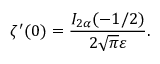Convert formula to latex. <formula><loc_0><loc_0><loc_500><loc_500>\zeta ^ { \prime } ( 0 ) = \frac { I _ { 2 \alpha } ( - 1 / 2 ) } { 2 \sqrt { \pi } \varepsilon } { . }</formula> 